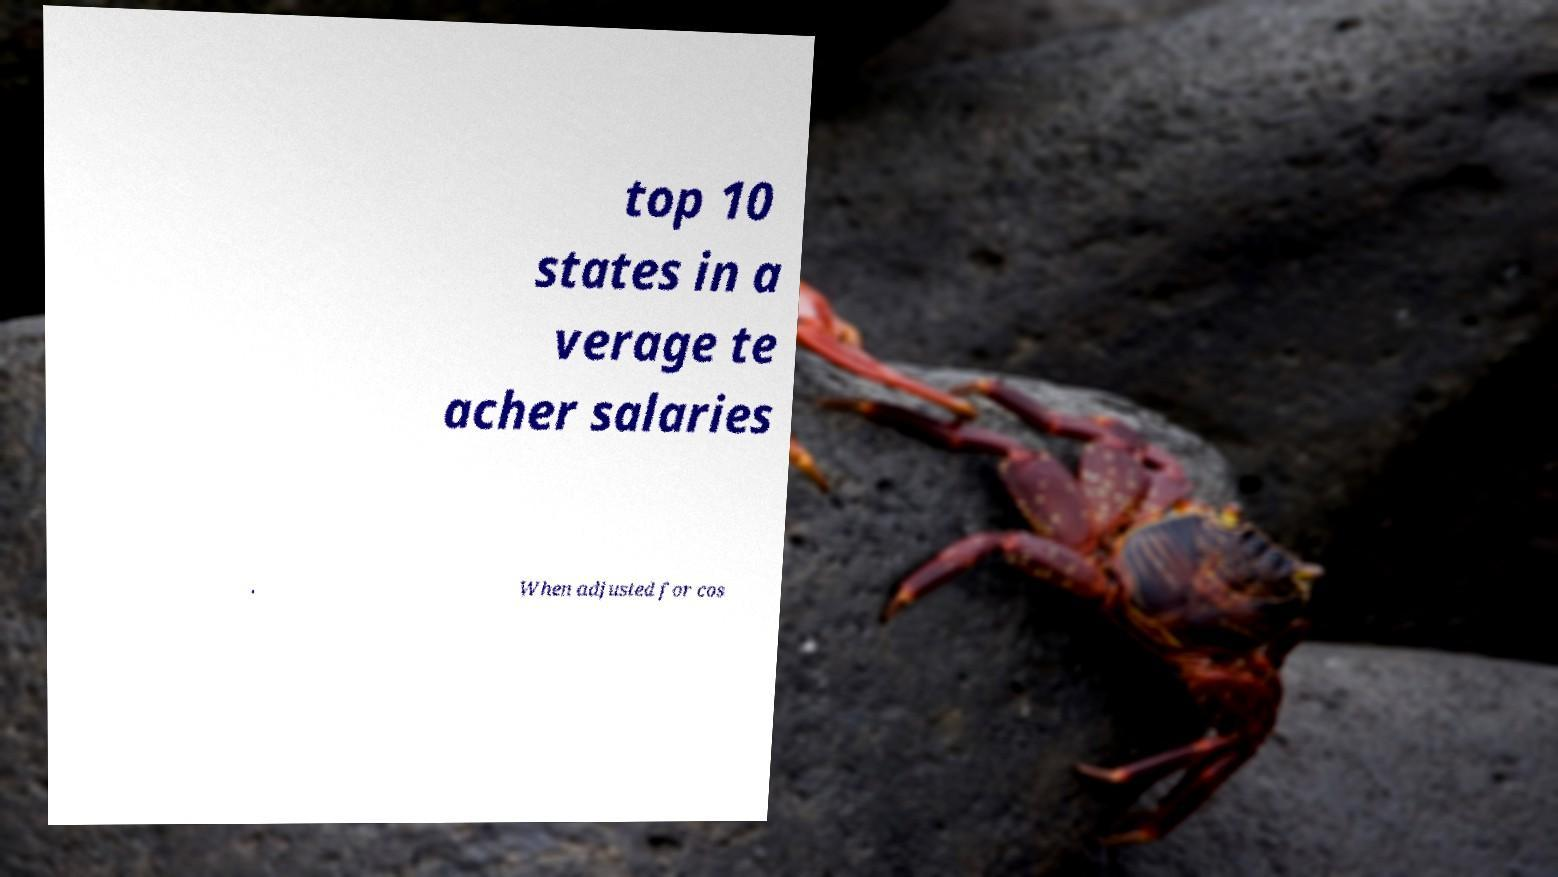There's text embedded in this image that I need extracted. Can you transcribe it verbatim? top 10 states in a verage te acher salaries . When adjusted for cos 